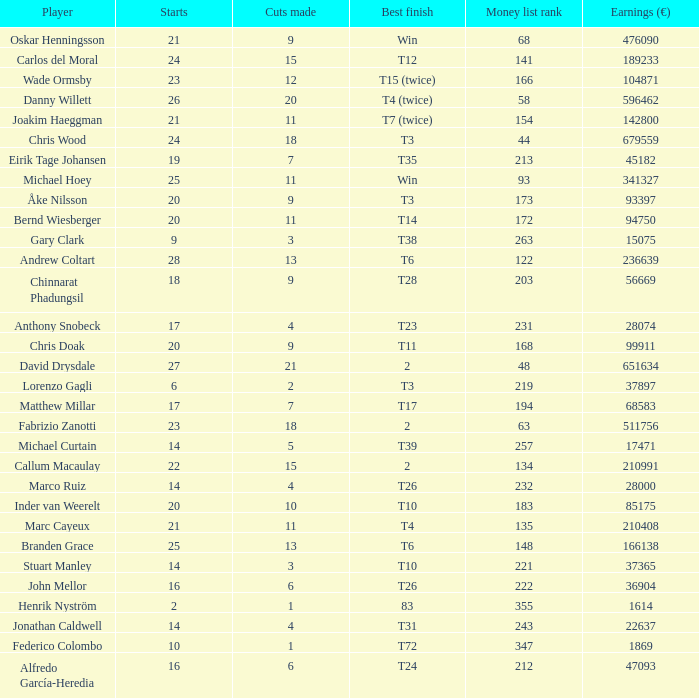Which athlete had precisely 26 starts? Danny Willett. 